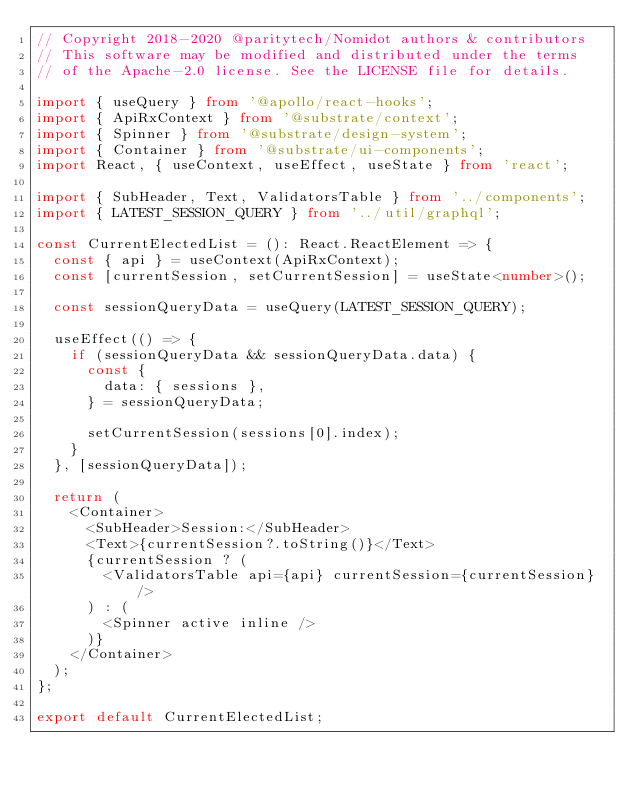Convert code to text. <code><loc_0><loc_0><loc_500><loc_500><_TypeScript_>// Copyright 2018-2020 @paritytech/Nomidot authors & contributors
// This software may be modified and distributed under the terms
// of the Apache-2.0 license. See the LICENSE file for details.

import { useQuery } from '@apollo/react-hooks';
import { ApiRxContext } from '@substrate/context';
import { Spinner } from '@substrate/design-system';
import { Container } from '@substrate/ui-components';
import React, { useContext, useEffect, useState } from 'react';

import { SubHeader, Text, ValidatorsTable } from '../components';
import { LATEST_SESSION_QUERY } from '../util/graphql';

const CurrentElectedList = (): React.ReactElement => {
  const { api } = useContext(ApiRxContext);
  const [currentSession, setCurrentSession] = useState<number>();

  const sessionQueryData = useQuery(LATEST_SESSION_QUERY);

  useEffect(() => {
    if (sessionQueryData && sessionQueryData.data) {
      const {
        data: { sessions },
      } = sessionQueryData;

      setCurrentSession(sessions[0].index);
    }
  }, [sessionQueryData]);

  return (
    <Container>
      <SubHeader>Session:</SubHeader>
      <Text>{currentSession?.toString()}</Text>
      {currentSession ? (
        <ValidatorsTable api={api} currentSession={currentSession} />
      ) : (
        <Spinner active inline />
      )}
    </Container>
  );
};

export default CurrentElectedList;
</code> 